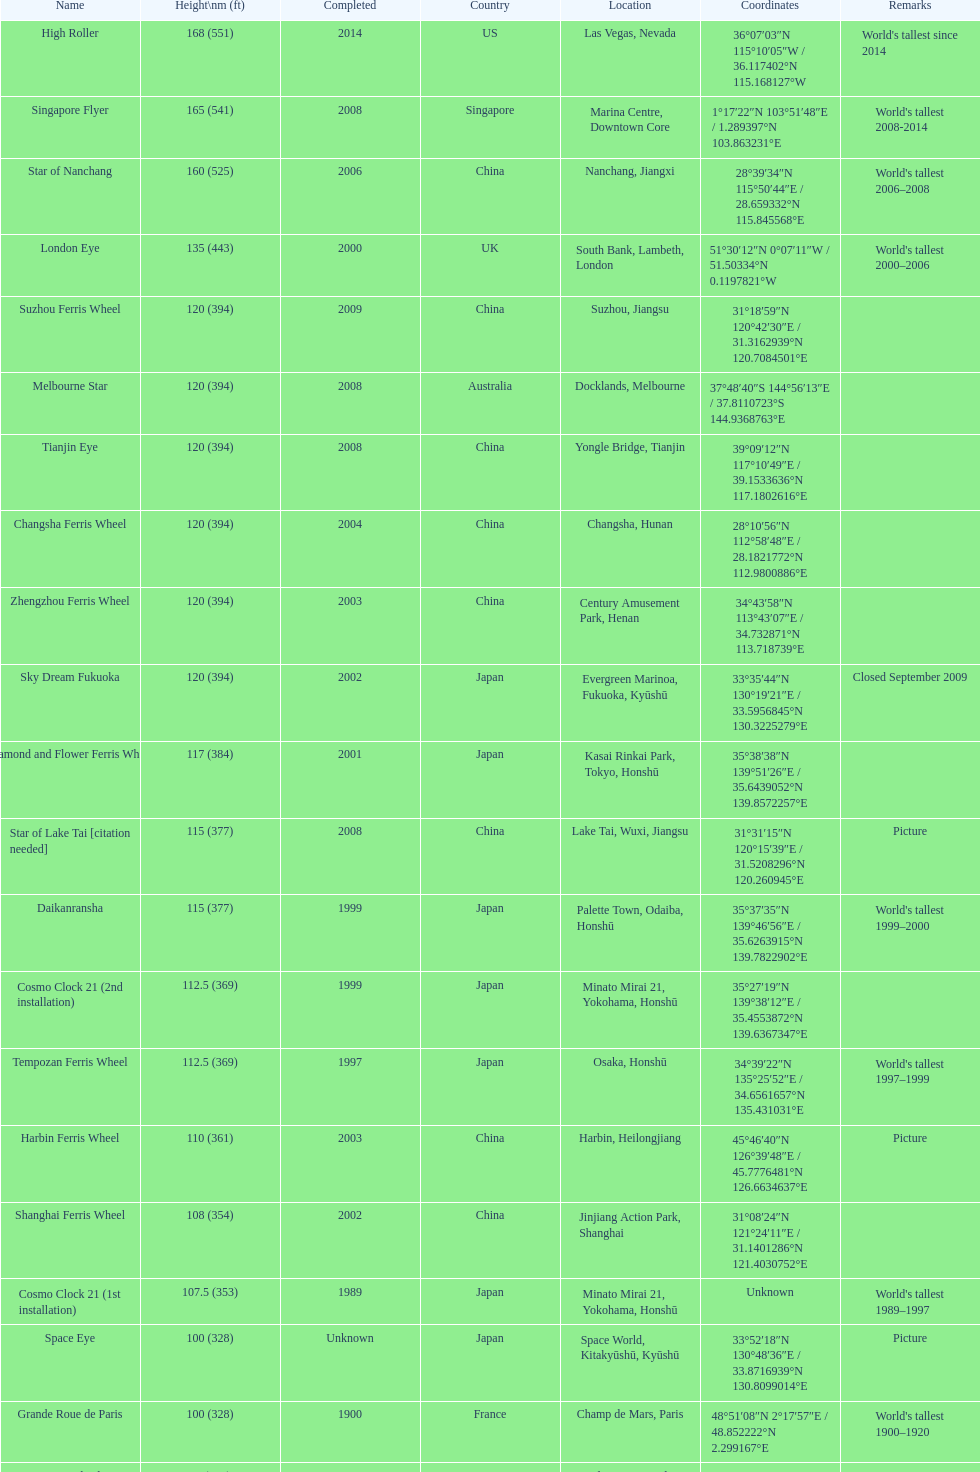Which of the following roller coasters is the oldest: star of lake tai, star of nanchang, melbourne star Star of Nanchang. 